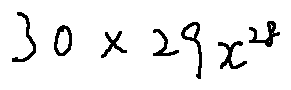<formula> <loc_0><loc_0><loc_500><loc_500>3 0 \times 2 9 x ^ { 2 8 }</formula> 